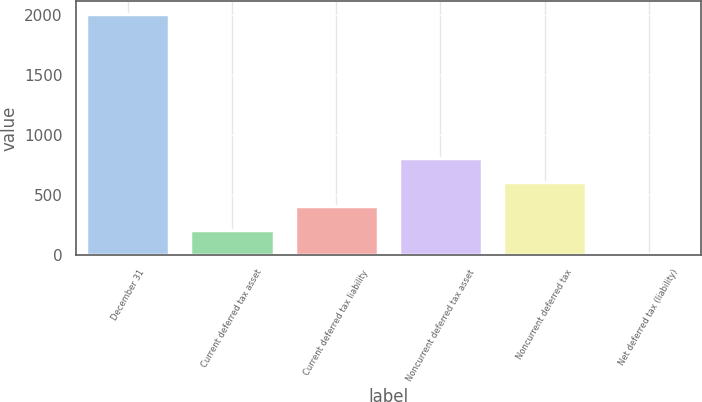Convert chart to OTSL. <chart><loc_0><loc_0><loc_500><loc_500><bar_chart><fcel>December 31<fcel>Current deferred tax asset<fcel>Current deferred tax liability<fcel>Noncurrent deferred tax asset<fcel>Noncurrent deferred tax<fcel>Net deferred tax (liability)<nl><fcel>2008<fcel>207.1<fcel>407.2<fcel>807.4<fcel>607.3<fcel>7<nl></chart> 